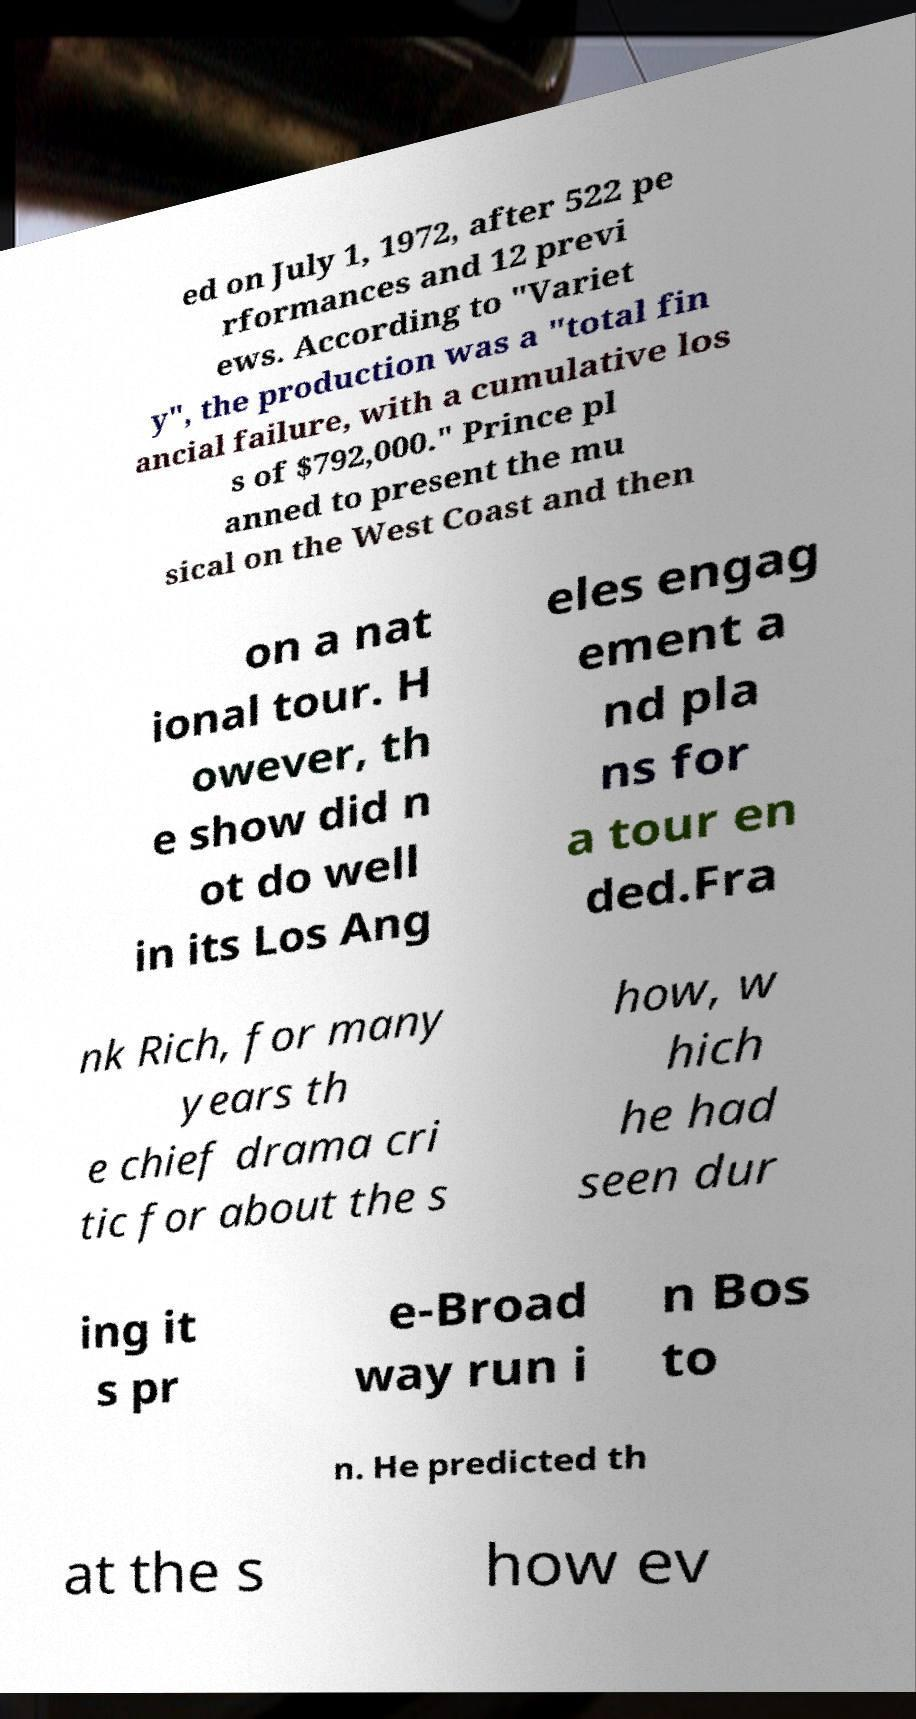Could you extract and type out the text from this image? ed on July 1, 1972, after 522 pe rformances and 12 previ ews. According to "Variet y", the production was a "total fin ancial failure, with a cumulative los s of $792,000." Prince pl anned to present the mu sical on the West Coast and then on a nat ional tour. H owever, th e show did n ot do well in its Los Ang eles engag ement a nd pla ns for a tour en ded.Fra nk Rich, for many years th e chief drama cri tic for about the s how, w hich he had seen dur ing it s pr e-Broad way run i n Bos to n. He predicted th at the s how ev 